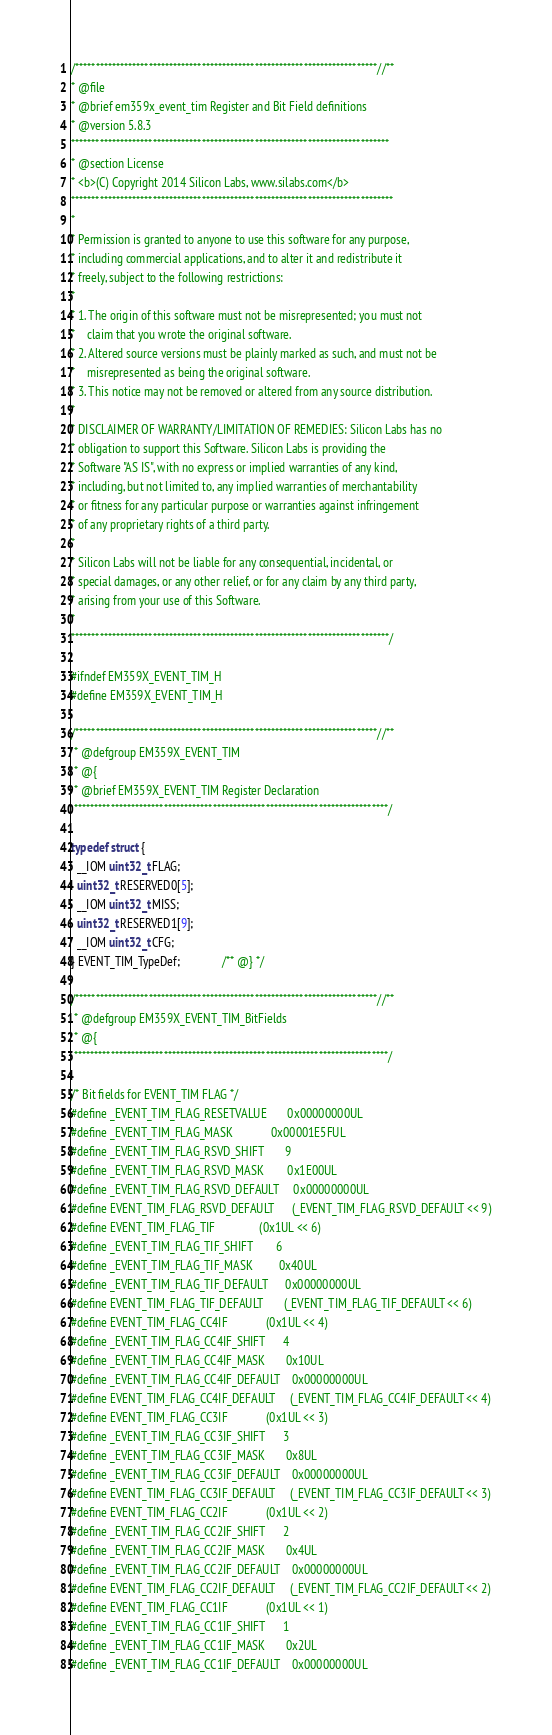<code> <loc_0><loc_0><loc_500><loc_500><_C_>/**************************************************************************//**
* @file
* @brief em359x_event_tim Register and Bit Field definitions
* @version 5.8.3
******************************************************************************
* @section License
* <b>(C) Copyright 2014 Silicon Labs, www.silabs.com</b>
*******************************************************************************
*
* Permission is granted to anyone to use this software for any purpose,
* including commercial applications, and to alter it and redistribute it
* freely, subject to the following restrictions:
*
* 1. The origin of this software must not be misrepresented; you must not
*    claim that you wrote the original software.
* 2. Altered source versions must be plainly marked as such, and must not be
*    misrepresented as being the original software.
* 3. This notice may not be removed or altered from any source distribution.
*
* DISCLAIMER OF WARRANTY/LIMITATION OF REMEDIES: Silicon Labs has no
* obligation to support this Software. Silicon Labs is providing the
* Software "AS IS", with no express or implied warranties of any kind,
* including, but not limited to, any implied warranties of merchantability
* or fitness for any particular purpose or warranties against infringement
* of any proprietary rights of a third party.
*
* Silicon Labs will not be liable for any consequential, incidental, or
* special damages, or any other relief, or for any claim by any third party,
* arising from your use of this Software.
*
******************************************************************************/

#ifndef EM359X_EVENT_TIM_H
#define EM359X_EVENT_TIM_H

/**************************************************************************//**
 * @defgroup EM359X_EVENT_TIM
 * @{
 * @brief EM359X_EVENT_TIM Register Declaration
 *****************************************************************************/

typedef struct {
  __IOM uint32_t FLAG;
  uint32_t RESERVED0[5];
  __IOM uint32_t MISS;
  uint32_t RESERVED1[9];
  __IOM uint32_t CFG;
} EVENT_TIM_TypeDef;              /** @} */

/**************************************************************************//**
 * @defgroup EM359X_EVENT_TIM_BitFields
 * @{
 *****************************************************************************/

/* Bit fields for EVENT_TIM FLAG */
#define _EVENT_TIM_FLAG_RESETVALUE       0x00000000UL
#define _EVENT_TIM_FLAG_MASK             0x00001E5FUL
#define _EVENT_TIM_FLAG_RSVD_SHIFT       9
#define _EVENT_TIM_FLAG_RSVD_MASK        0x1E00UL
#define _EVENT_TIM_FLAG_RSVD_DEFAULT     0x00000000UL
#define EVENT_TIM_FLAG_RSVD_DEFAULT      (_EVENT_TIM_FLAG_RSVD_DEFAULT << 9)
#define EVENT_TIM_FLAG_TIF               (0x1UL << 6)
#define _EVENT_TIM_FLAG_TIF_SHIFT        6
#define _EVENT_TIM_FLAG_TIF_MASK         0x40UL
#define _EVENT_TIM_FLAG_TIF_DEFAULT      0x00000000UL
#define EVENT_TIM_FLAG_TIF_DEFAULT       (_EVENT_TIM_FLAG_TIF_DEFAULT << 6)
#define EVENT_TIM_FLAG_CC4IF             (0x1UL << 4)
#define _EVENT_TIM_FLAG_CC4IF_SHIFT      4
#define _EVENT_TIM_FLAG_CC4IF_MASK       0x10UL
#define _EVENT_TIM_FLAG_CC4IF_DEFAULT    0x00000000UL
#define EVENT_TIM_FLAG_CC4IF_DEFAULT     (_EVENT_TIM_FLAG_CC4IF_DEFAULT << 4)
#define EVENT_TIM_FLAG_CC3IF             (0x1UL << 3)
#define _EVENT_TIM_FLAG_CC3IF_SHIFT      3
#define _EVENT_TIM_FLAG_CC3IF_MASK       0x8UL
#define _EVENT_TIM_FLAG_CC3IF_DEFAULT    0x00000000UL
#define EVENT_TIM_FLAG_CC3IF_DEFAULT     (_EVENT_TIM_FLAG_CC3IF_DEFAULT << 3)
#define EVENT_TIM_FLAG_CC2IF             (0x1UL << 2)
#define _EVENT_TIM_FLAG_CC2IF_SHIFT      2
#define _EVENT_TIM_FLAG_CC2IF_MASK       0x4UL
#define _EVENT_TIM_FLAG_CC2IF_DEFAULT    0x00000000UL
#define EVENT_TIM_FLAG_CC2IF_DEFAULT     (_EVENT_TIM_FLAG_CC2IF_DEFAULT << 2)
#define EVENT_TIM_FLAG_CC1IF             (0x1UL << 1)
#define _EVENT_TIM_FLAG_CC1IF_SHIFT      1
#define _EVENT_TIM_FLAG_CC1IF_MASK       0x2UL
#define _EVENT_TIM_FLAG_CC1IF_DEFAULT    0x00000000UL</code> 